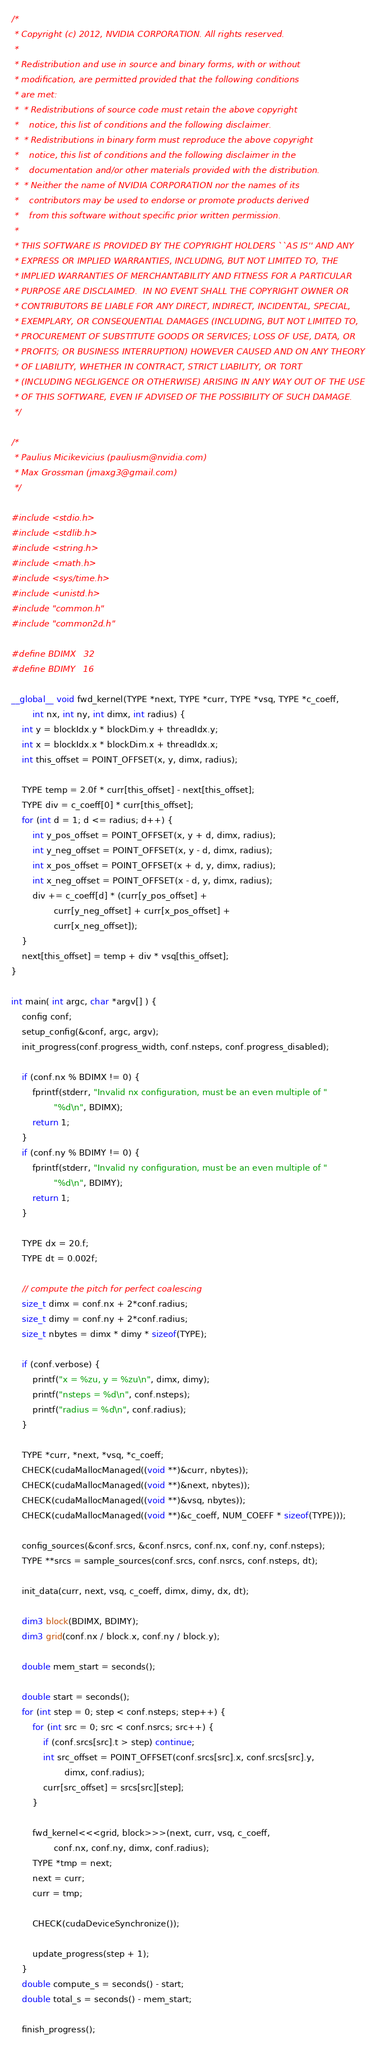Convert code to text. <code><loc_0><loc_0><loc_500><loc_500><_Cuda_>/*
 * Copyright (c) 2012, NVIDIA CORPORATION. All rights reserved.
 *
 * Redistribution and use in source and binary forms, with or without
 * modification, are permitted provided that the following conditions
 * are met:
 *  * Redistributions of source code must retain the above copyright
 *    notice, this list of conditions and the following disclaimer.
 *  * Redistributions in binary form must reproduce the above copyright
 *    notice, this list of conditions and the following disclaimer in the
 *    documentation and/or other materials provided with the distribution.
 *  * Neither the name of NVIDIA CORPORATION nor the names of its
 *    contributors may be used to endorse or promote products derived 
 *    from this software without specific prior written permission.
 * 
 * THIS SOFTWARE IS PROVIDED BY THE COPYRIGHT HOLDERS ``AS IS'' AND ANY
 * EXPRESS OR IMPLIED WARRANTIES, INCLUDING, BUT NOT LIMITED TO, THE
 * IMPLIED WARRANTIES OF MERCHANTABILITY AND FITNESS FOR A PARTICULAR
 * PURPOSE ARE DISCLAIMED.  IN NO EVENT SHALL THE COPYRIGHT OWNER OR
 * CONTRIBUTORS BE LIABLE FOR ANY DIRECT, INDIRECT, INCIDENTAL, SPECIAL,
 * EXEMPLARY, OR CONSEQUENTIAL DAMAGES (INCLUDING, BUT NOT LIMITED TO,
 * PROCUREMENT OF SUBSTITUTE GOODS OR SERVICES; LOSS OF USE, DATA, OR
 * PROFITS; OR BUSINESS INTERRUPTION) HOWEVER CAUSED AND ON ANY THEORY
 * OF LIABILITY, WHETHER IN CONTRACT, STRICT LIABILITY, OR TORT
 * (INCLUDING NEGLIGENCE OR OTHERWISE) ARISING IN ANY WAY OUT OF THE USE
 * OF THIS SOFTWARE, EVEN IF ADVISED OF THE POSSIBILITY OF SUCH DAMAGE.
 */

/*
 * Paulius Micikevicius (pauliusm@nvidia.com)
 * Max Grossman (jmaxg3@gmail.com)
 */

#include <stdio.h>
#include <stdlib.h>
#include <string.h>
#include <math.h>
#include <sys/time.h>
#include <unistd.h>
#include "common.h"
#include "common2d.h"

#define BDIMX   32
#define BDIMY   16

__global__ void fwd_kernel(TYPE *next, TYPE *curr, TYPE *vsq, TYPE *c_coeff,
        int nx, int ny, int dimx, int radius) {
    int y = blockIdx.y * blockDim.y + threadIdx.y;
    int x = blockIdx.x * blockDim.x + threadIdx.x;
    int this_offset = POINT_OFFSET(x, y, dimx, radius);

    TYPE temp = 2.0f * curr[this_offset] - next[this_offset];
    TYPE div = c_coeff[0] * curr[this_offset];
    for (int d = 1; d <= radius; d++) {
        int y_pos_offset = POINT_OFFSET(x, y + d, dimx, radius);
        int y_neg_offset = POINT_OFFSET(x, y - d, dimx, radius);
        int x_pos_offset = POINT_OFFSET(x + d, y, dimx, radius);
        int x_neg_offset = POINT_OFFSET(x - d, y, dimx, radius);
        div += c_coeff[d] * (curr[y_pos_offset] +
                curr[y_neg_offset] + curr[x_pos_offset] +
                curr[x_neg_offset]);
    }
    next[this_offset] = temp + div * vsq[this_offset];
}

int main( int argc, char *argv[] ) {
    config conf;
    setup_config(&conf, argc, argv);
    init_progress(conf.progress_width, conf.nsteps, conf.progress_disabled);

    if (conf.nx % BDIMX != 0) {
        fprintf(stderr, "Invalid nx configuration, must be an even multiple of "
                "%d\n", BDIMX);
        return 1;
    }
    if (conf.ny % BDIMY != 0) {
        fprintf(stderr, "Invalid ny configuration, must be an even multiple of "
                "%d\n", BDIMY);
        return 1;
    }

    TYPE dx = 20.f;
    TYPE dt = 0.002f;

    // compute the pitch for perfect coalescing
    size_t dimx = conf.nx + 2*conf.radius;
    size_t dimy = conf.ny + 2*conf.radius;
    size_t nbytes = dimx * dimy * sizeof(TYPE);

    if (conf.verbose) {
        printf("x = %zu, y = %zu\n", dimx, dimy);
        printf("nsteps = %d\n", conf.nsteps);
        printf("radius = %d\n", conf.radius);
    }

    TYPE *curr, *next, *vsq, *c_coeff;
    CHECK(cudaMallocManaged((void **)&curr, nbytes));
    CHECK(cudaMallocManaged((void **)&next, nbytes));
    CHECK(cudaMallocManaged((void **)&vsq, nbytes));
    CHECK(cudaMallocManaged((void **)&c_coeff, NUM_COEFF * sizeof(TYPE)));

    config_sources(&conf.srcs, &conf.nsrcs, conf.nx, conf.ny, conf.nsteps);
    TYPE **srcs = sample_sources(conf.srcs, conf.nsrcs, conf.nsteps, dt);

    init_data(curr, next, vsq, c_coeff, dimx, dimy, dx, dt);

    dim3 block(BDIMX, BDIMY);
    dim3 grid(conf.nx / block.x, conf.ny / block.y);

    double mem_start = seconds();

    double start = seconds();
    for (int step = 0; step < conf.nsteps; step++) {
        for (int src = 0; src < conf.nsrcs; src++) {
            if (conf.srcs[src].t > step) continue;
            int src_offset = POINT_OFFSET(conf.srcs[src].x, conf.srcs[src].y,
                    dimx, conf.radius);
            curr[src_offset] = srcs[src][step];
        }

        fwd_kernel<<<grid, block>>>(next, curr, vsq, c_coeff,
                conf.nx, conf.ny, dimx, conf.radius);
        TYPE *tmp = next;
        next = curr;
        curr = tmp;

        CHECK(cudaDeviceSynchronize());

        update_progress(step + 1);
    }
    double compute_s = seconds() - start;
    double total_s = seconds() - mem_start;

    finish_progress();
</code> 